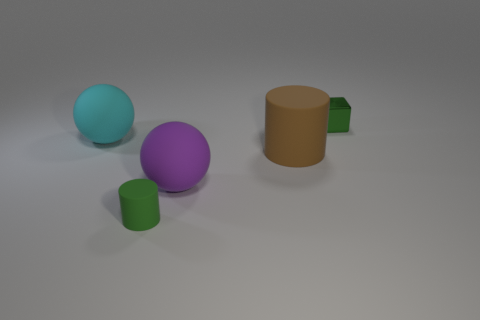There is a object that is the same color as the small block; what shape is it?
Give a very brief answer. Cylinder. What material is the green thing that is in front of the big matte sphere that is to the left of the large purple rubber ball?
Offer a very short reply. Rubber. There is a green thing to the left of the small shiny cube; does it have the same size as the cylinder that is behind the large purple matte ball?
Offer a terse response. No. Are there any other things that have the same material as the tiny block?
Offer a very short reply. No. How many tiny objects are either cyan rubber balls or blue matte blocks?
Keep it short and to the point. 0. What number of things are either large balls that are in front of the cyan thing or big brown cylinders?
Ensure brevity in your answer.  2. Do the small shiny cube and the tiny matte cylinder have the same color?
Give a very brief answer. Yes. How many other objects are the same shape as the shiny thing?
Provide a succinct answer. 0. How many brown things are big matte cylinders or tiny shiny things?
Your answer should be compact. 1. The tiny object that is made of the same material as the large purple thing is what color?
Offer a terse response. Green. 